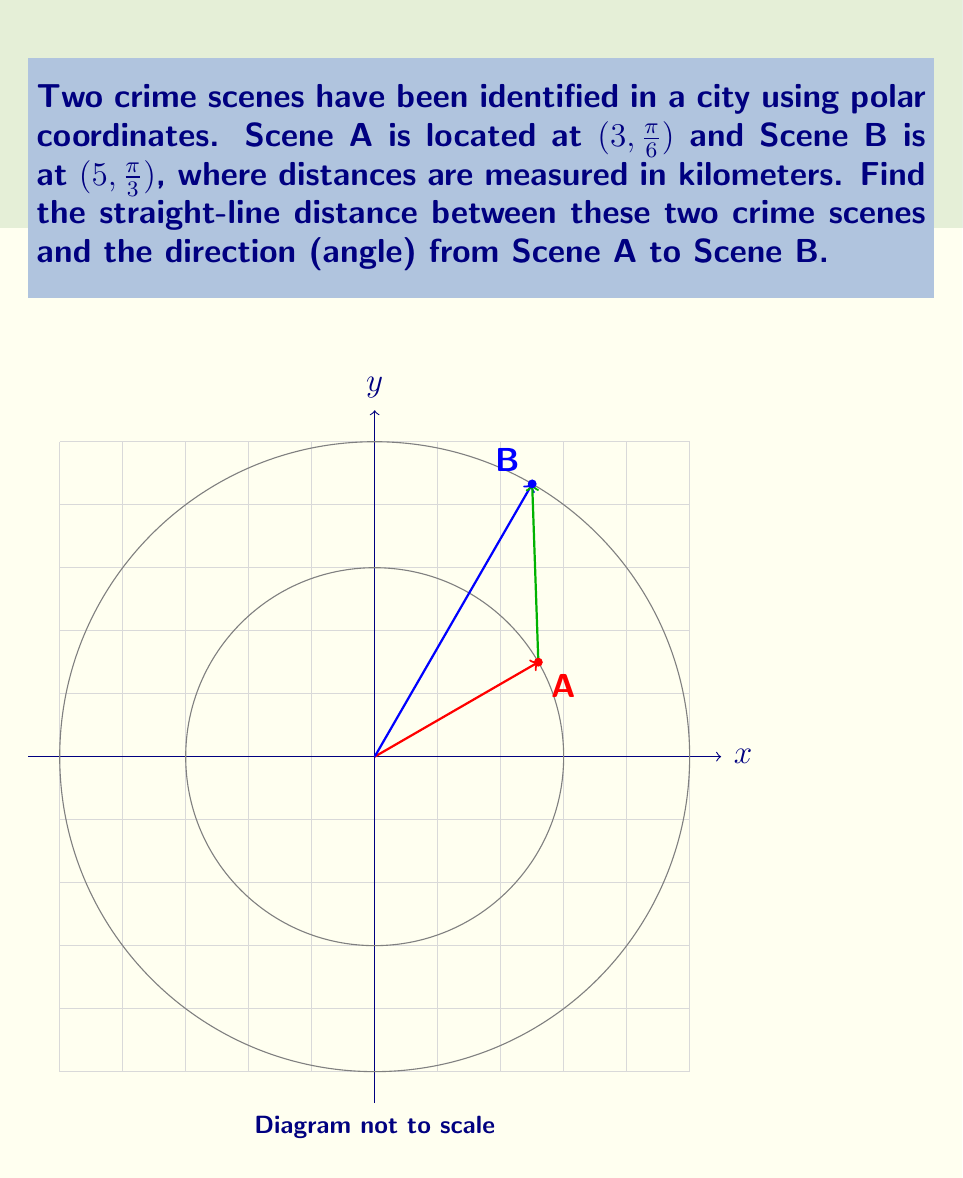Could you help me with this problem? To solve this problem, we'll use the polar form of the distance formula and the angle between two points.

Step 1: Convert polar coordinates to Cartesian coordinates
Scene A: $(r_1, \theta_1) = (3, \frac{\pi}{6})$
$x_1 = r_1 \cos(\theta_1) = 3 \cos(\frac{\pi}{6}) = 3 \cdot \frac{\sqrt{3}}{2} = \frac{3\sqrt{3}}{2}$
$y_1 = r_1 \sin(\theta_1) = 3 \sin(\frac{\pi}{6}) = 3 \cdot \frac{1}{2} = \frac{3}{2}$

Scene B: $(r_2, \theta_2) = (5, \frac{\pi}{3})$
$x_2 = r_2 \cos(\theta_2) = 5 \cos(\frac{\pi}{3}) = 5 \cdot \frac{1}{2} = \frac{5}{2}$
$y_2 = r_2 \sin(\theta_2) = 5 \sin(\frac{\pi}{3}) = 5 \cdot \frac{\sqrt{3}}{2} = \frac{5\sqrt{3}}{2}$

Step 2: Calculate the distance using the distance formula
$d = \sqrt{(x_2 - x_1)^2 + (y_2 - y_1)^2}$
$d = \sqrt{(\frac{5}{2} - \frac{3\sqrt{3}}{2})^2 + (\frac{5\sqrt{3}}{2} - \frac{3}{2})^2}$
$d = \sqrt{\frac{25}{4} + \frac{27}{4} - 5\sqrt{3} + \frac{75}{4} + \frac{9}{4} - 5\sqrt{3}}$
$d = \sqrt{\frac{136}{4} - 10\sqrt{3}} = \sqrt{34 - 10\sqrt{3}}$

Step 3: Calculate the direction (angle) from A to B
$\theta = \arctan2(y_2 - y_1, x_2 - x_1) - \theta_1$
$\theta = \arctan2(\frac{5\sqrt{3}}{2} - \frac{3}{2}, \frac{5}{2} - \frac{3\sqrt{3}}{2}) - \frac{\pi}{6}$
$\theta = \arctan2(5\sqrt{3} - 3, 5 - 3\sqrt{3}) - \frac{\pi}{6}$
$\theta = \arctan2(5\sqrt{3} - 3, 5 - 3\sqrt{3}) - \frac{\pi}{6}$

Note: The $\arctan2$ function is used to get the correct quadrant for the angle.
Answer: Distance: $\sqrt{34 - 10\sqrt{3}}$ km
Direction: $\arctan2(5\sqrt{3} - 3, 5 - 3\sqrt{3}) - \frac{\pi}{6}$ radians 